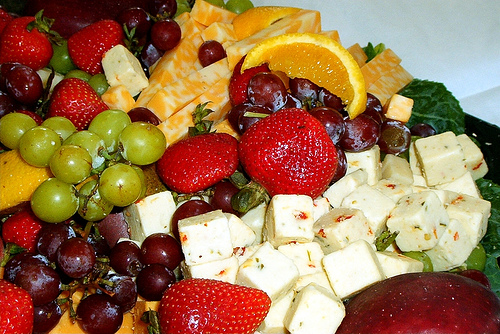<image>
Can you confirm if the cheese is on the strawberry? No. The cheese is not positioned on the strawberry. They may be near each other, but the cheese is not supported by or resting on top of the strawberry. Is the strawberry under the other strawberry? No. The strawberry is not positioned under the other strawberry. The vertical relationship between these objects is different. 